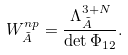<formula> <loc_0><loc_0><loc_500><loc_500>W ^ { n p } _ { \tilde { A } } = \frac { \Lambda ^ { 3 + N } _ { \tilde { A } } } { \det \Phi _ { 1 2 } } .</formula> 